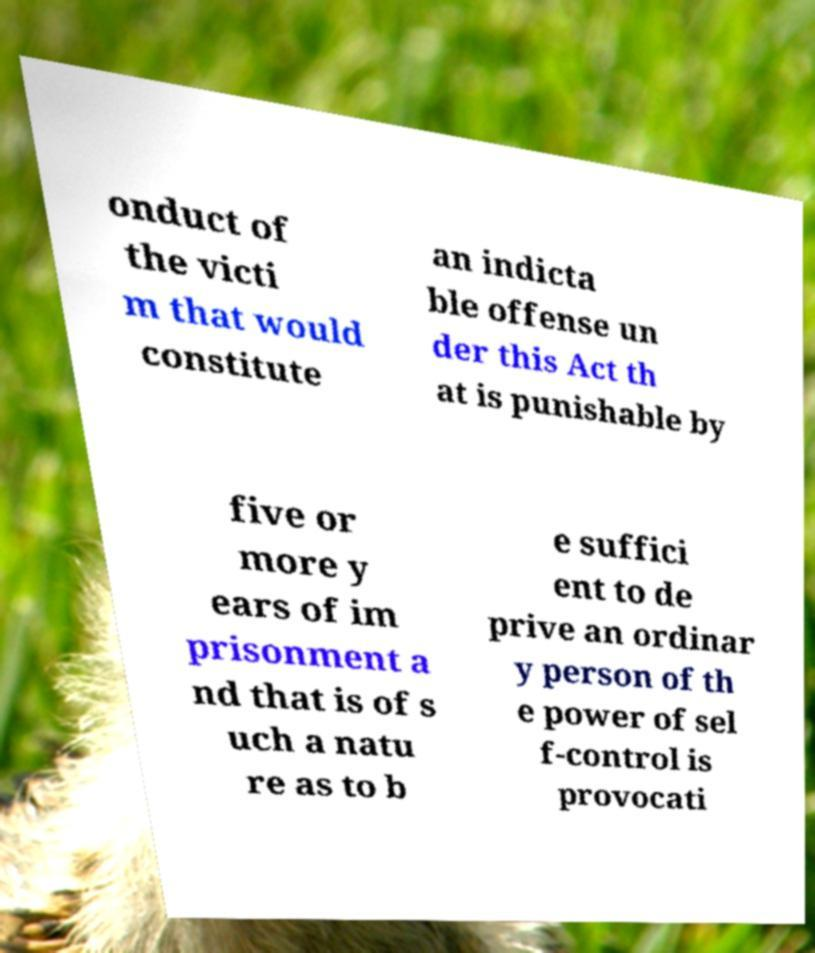Please identify and transcribe the text found in this image. onduct of the victi m that would constitute an indicta ble offense un der this Act th at is punishable by five or more y ears of im prisonment a nd that is of s uch a natu re as to b e suffici ent to de prive an ordinar y person of th e power of sel f-control is provocati 